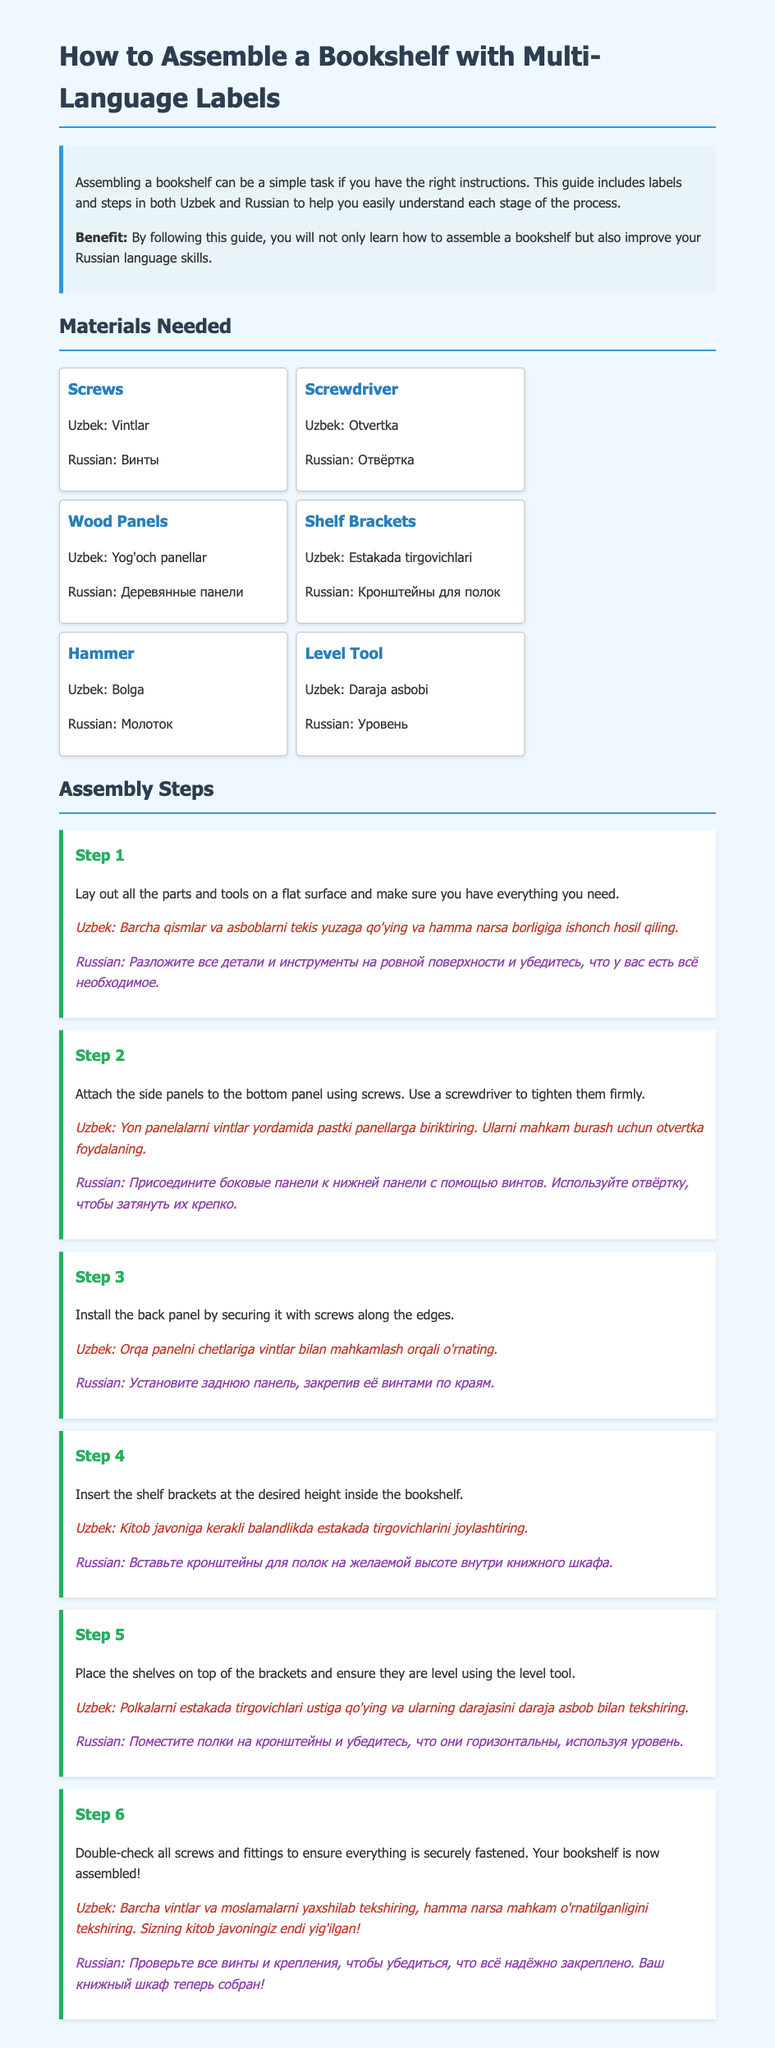What is the first step in assembling the bookshelf? The first step is to lay out all the parts and tools on a flat surface and make sure you have everything you need.
Answer: Lay out all the parts and tools What is the Uzbek term for screws? The Uzbek term for screws is mentioned in the materials section.
Answer: Vintlar How many steps are there in the assembly instructions? The document lists each step of the assembly process numerically.
Answer: 6 What tool is used to ensure shelves are level? The document specifies the tool used for leveling shelves.
Answer: Level Tool What should you check at the final step? The last step instructs to check the security of screws and fittings.
Answer: All screws and fittings What are the Russian and Uzbek terms for the hammer? The document provides the names of the hammer in both languages.
Answer: Молоток; Bolga What do you install at the desired height inside the bookshelf? The assembly instructions guide what to place inside the bookshelf.
Answer: Shelf Brackets What is the background color of the document? The style section of the document specifies the background color.
Answer: #f0f8ff What is the purpose of this guide according to the introduction? The introduction outlines the benefits of following the guide.
Answer: To help you easily understand each stage 